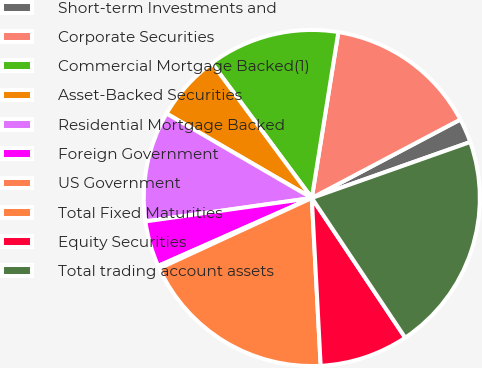Convert chart to OTSL. <chart><loc_0><loc_0><loc_500><loc_500><pie_chart><fcel>Short-term Investments and<fcel>Corporate Securities<fcel>Commercial Mortgage Backed(1)<fcel>Asset-Backed Securities<fcel>Residential Mortgage Backed<fcel>Foreign Government<fcel>US Government<fcel>Total Fixed Maturities<fcel>Equity Securities<fcel>Total trading account assets<nl><fcel>2.33%<fcel>14.74%<fcel>12.68%<fcel>6.47%<fcel>10.61%<fcel>4.4%<fcel>0.26%<fcel>18.96%<fcel>8.54%<fcel>21.03%<nl></chart> 